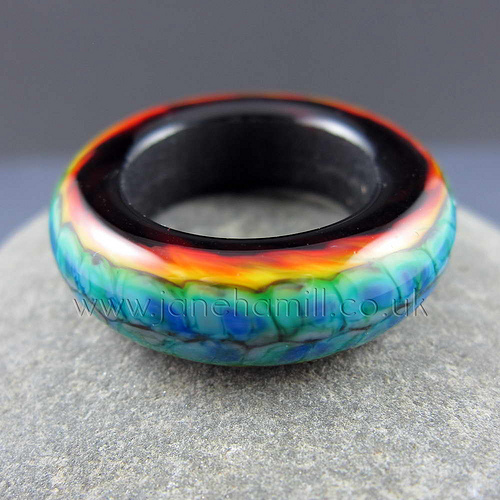<image>
Can you confirm if the rock is to the left of the ring? No. The rock is not to the left of the ring. From this viewpoint, they have a different horizontal relationship. 